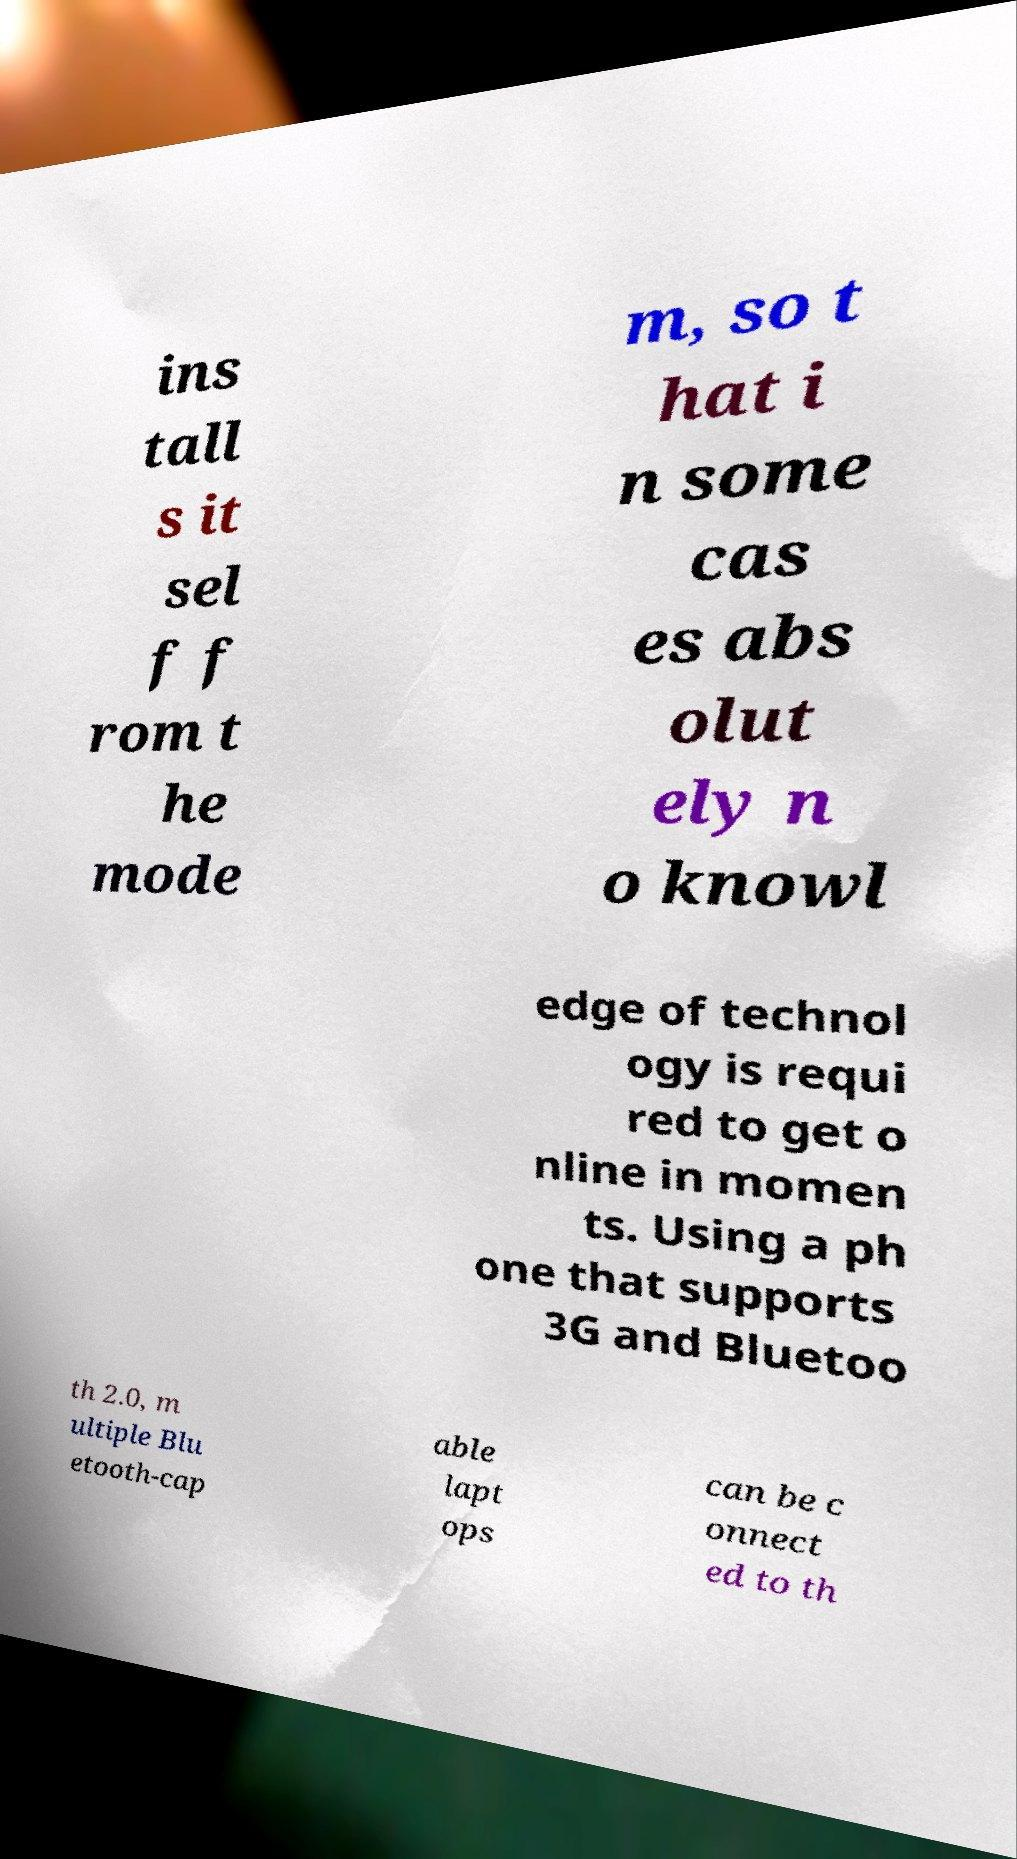Please identify and transcribe the text found in this image. ins tall s it sel f f rom t he mode m, so t hat i n some cas es abs olut ely n o knowl edge of technol ogy is requi red to get o nline in momen ts. Using a ph one that supports 3G and Bluetoo th 2.0, m ultiple Blu etooth-cap able lapt ops can be c onnect ed to th 